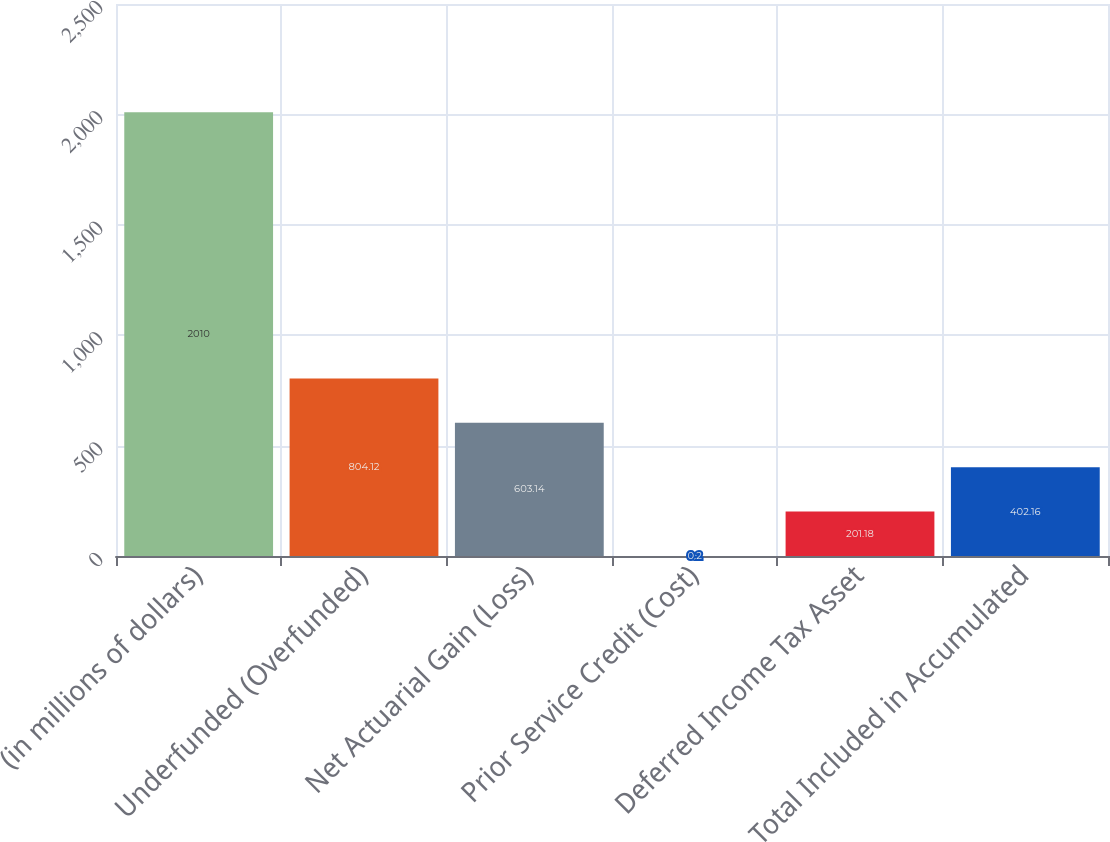Convert chart. <chart><loc_0><loc_0><loc_500><loc_500><bar_chart><fcel>(in millions of dollars)<fcel>Underfunded (Overfunded)<fcel>Net Actuarial Gain (Loss)<fcel>Prior Service Credit (Cost)<fcel>Deferred Income Tax Asset<fcel>Total Included in Accumulated<nl><fcel>2010<fcel>804.12<fcel>603.14<fcel>0.2<fcel>201.18<fcel>402.16<nl></chart> 